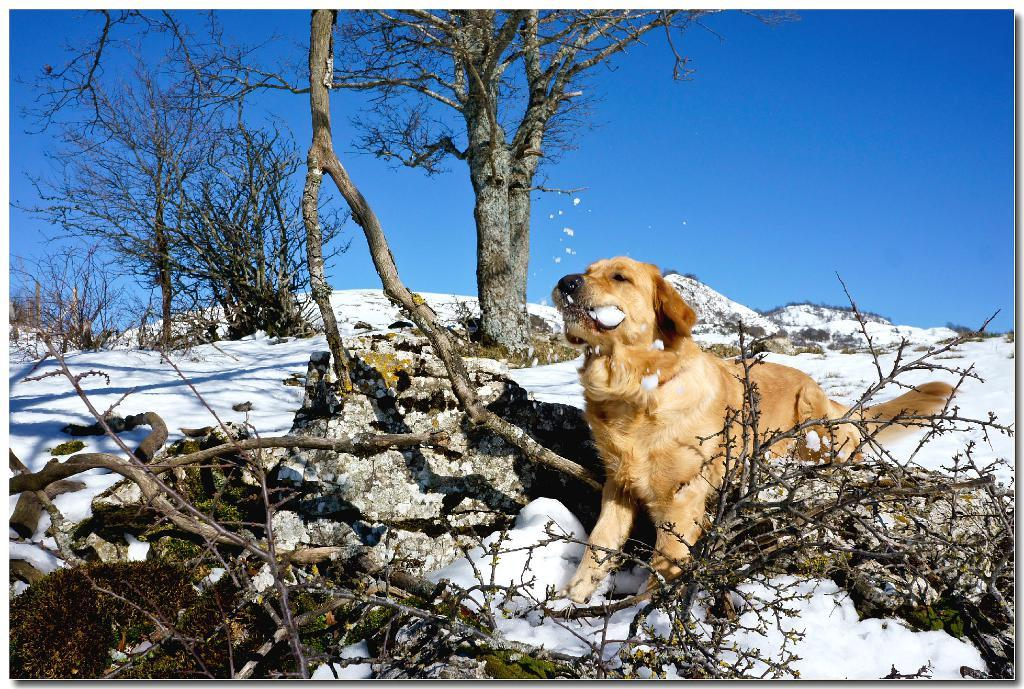What is the dog doing in the image? The dog is standing on the snow in the image. What can be seen in the foreground of the image? The branches of a tree are visible in the foreground. What is visible in the background of the image? There is a group of trees and the sky visible in the background. Is the dog wearing a scarf in the image? No, the dog is not wearing a scarf in the image. What type of trade is being conducted in the image? There is no trade being conducted in the image; it features a dog standing on the snow with a tree in the foreground and a group of trees and sky in the background. 